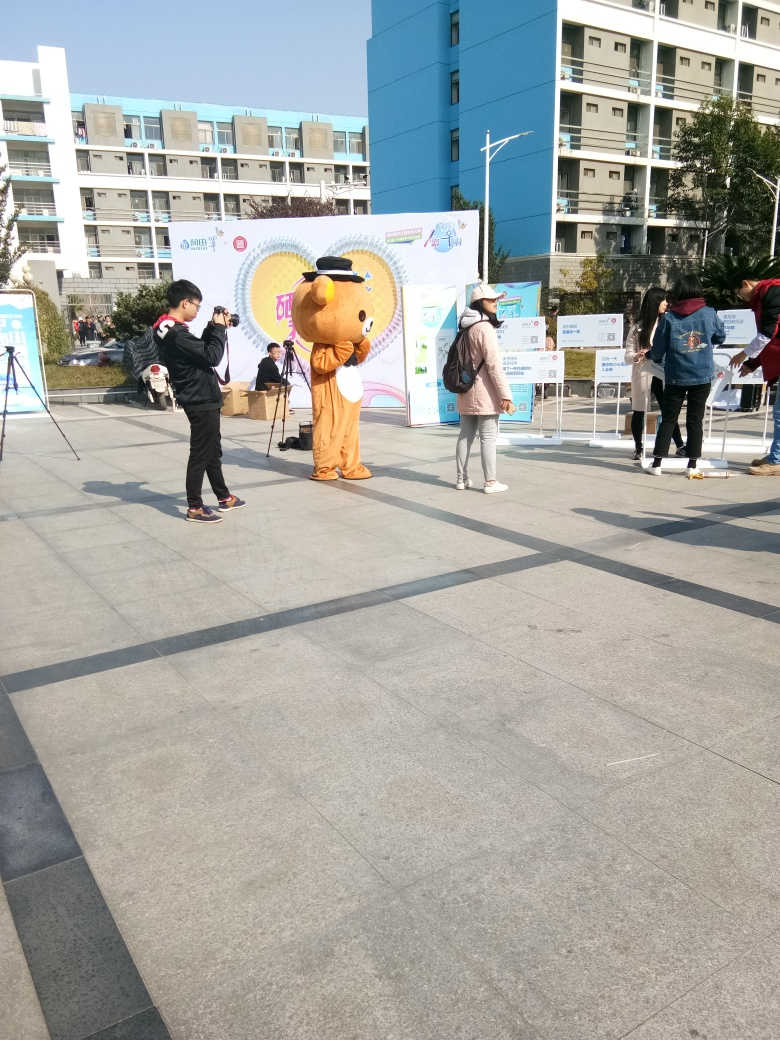Is there any blurriness in the image? The image appears clear and well-focused, with no significant signs of blurriness affecting the details. All the subjects, such as the person in the mascot costume and the individuals around them, as well as the surrounding environment including the banners and buildings in the background, are distinctly visible and sharp. 